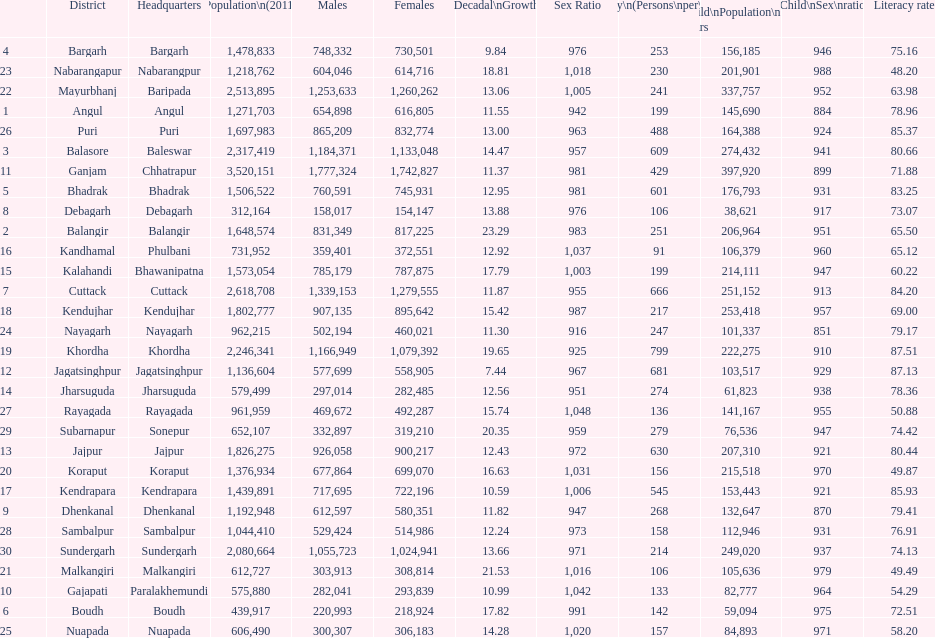Which district had the greatest number of inhabitants per square kilometer? Khordha. 